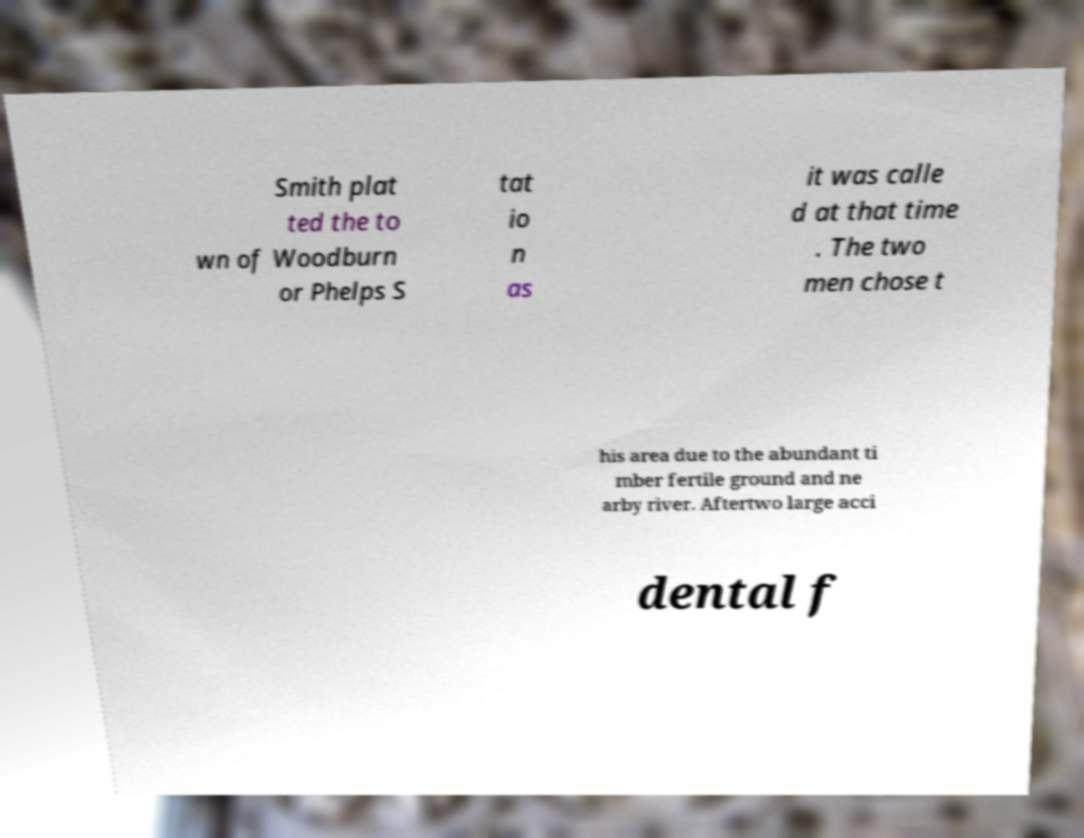Can you accurately transcribe the text from the provided image for me? Smith plat ted the to wn of Woodburn or Phelps S tat io n as it was calle d at that time . The two men chose t his area due to the abundant ti mber fertile ground and ne arby river. Aftertwo large acci dental f 